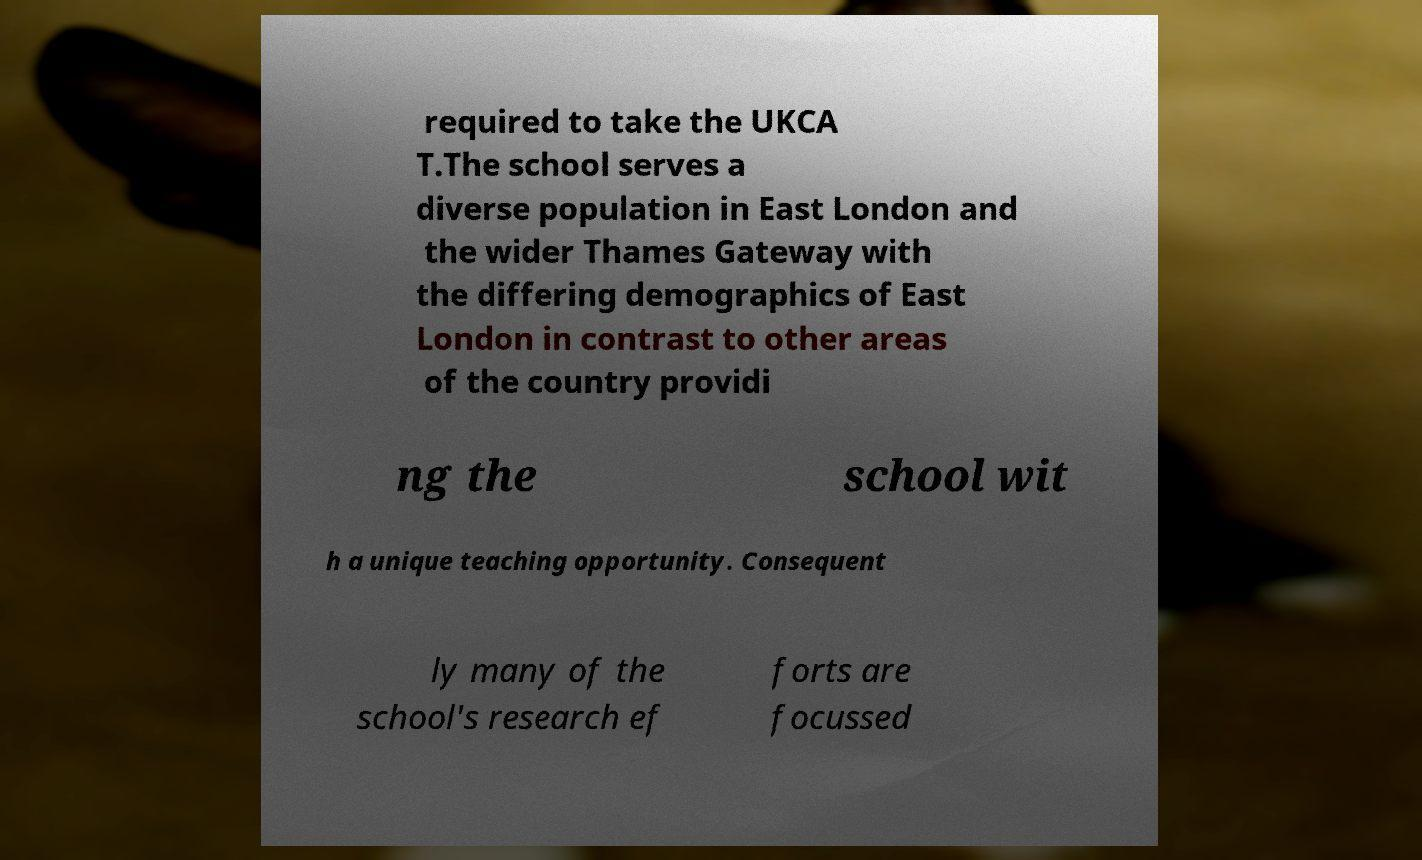Can you read and provide the text displayed in the image?This photo seems to have some interesting text. Can you extract and type it out for me? required to take the UKCA T.The school serves a diverse population in East London and the wider Thames Gateway with the differing demographics of East London in contrast to other areas of the country providi ng the school wit h a unique teaching opportunity. Consequent ly many of the school's research ef forts are focussed 